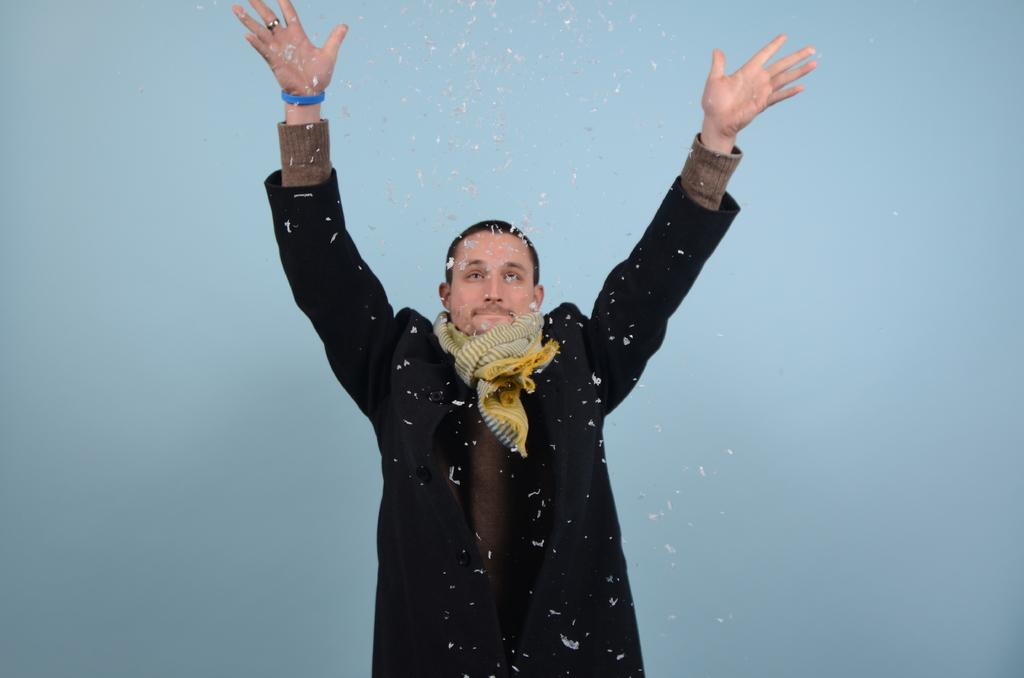What is the main subject of the image? There is a man standing in the image. What are the small white objects in the image? The small white objects are not specified in the facts, so we cannot definitively answer this question. What color is the background of the image? The background of the image is blue. Can you see a woman giving a pump to the man in the image? There is no woman or pump present in the image. Are the man and woman in the image sharing a kiss? There is no woman or kiss depicted in the image; it only features a man standing. 